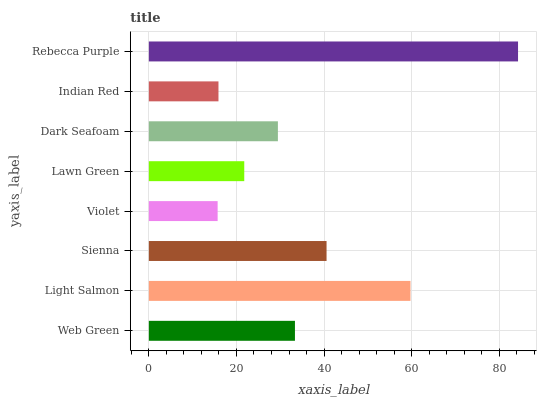Is Violet the minimum?
Answer yes or no. Yes. Is Rebecca Purple the maximum?
Answer yes or no. Yes. Is Light Salmon the minimum?
Answer yes or no. No. Is Light Salmon the maximum?
Answer yes or no. No. Is Light Salmon greater than Web Green?
Answer yes or no. Yes. Is Web Green less than Light Salmon?
Answer yes or no. Yes. Is Web Green greater than Light Salmon?
Answer yes or no. No. Is Light Salmon less than Web Green?
Answer yes or no. No. Is Web Green the high median?
Answer yes or no. Yes. Is Dark Seafoam the low median?
Answer yes or no. Yes. Is Lawn Green the high median?
Answer yes or no. No. Is Lawn Green the low median?
Answer yes or no. No. 